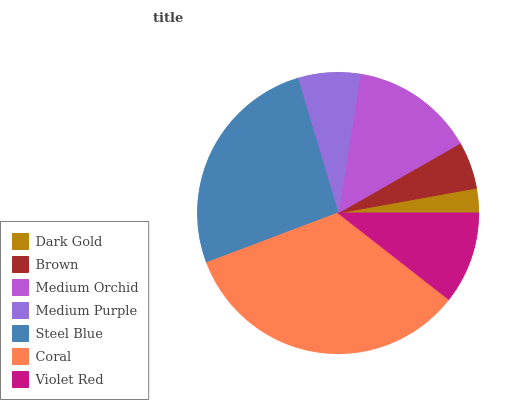Is Dark Gold the minimum?
Answer yes or no. Yes. Is Coral the maximum?
Answer yes or no. Yes. Is Brown the minimum?
Answer yes or no. No. Is Brown the maximum?
Answer yes or no. No. Is Brown greater than Dark Gold?
Answer yes or no. Yes. Is Dark Gold less than Brown?
Answer yes or no. Yes. Is Dark Gold greater than Brown?
Answer yes or no. No. Is Brown less than Dark Gold?
Answer yes or no. No. Is Violet Red the high median?
Answer yes or no. Yes. Is Violet Red the low median?
Answer yes or no. Yes. Is Medium Purple the high median?
Answer yes or no. No. Is Brown the low median?
Answer yes or no. No. 